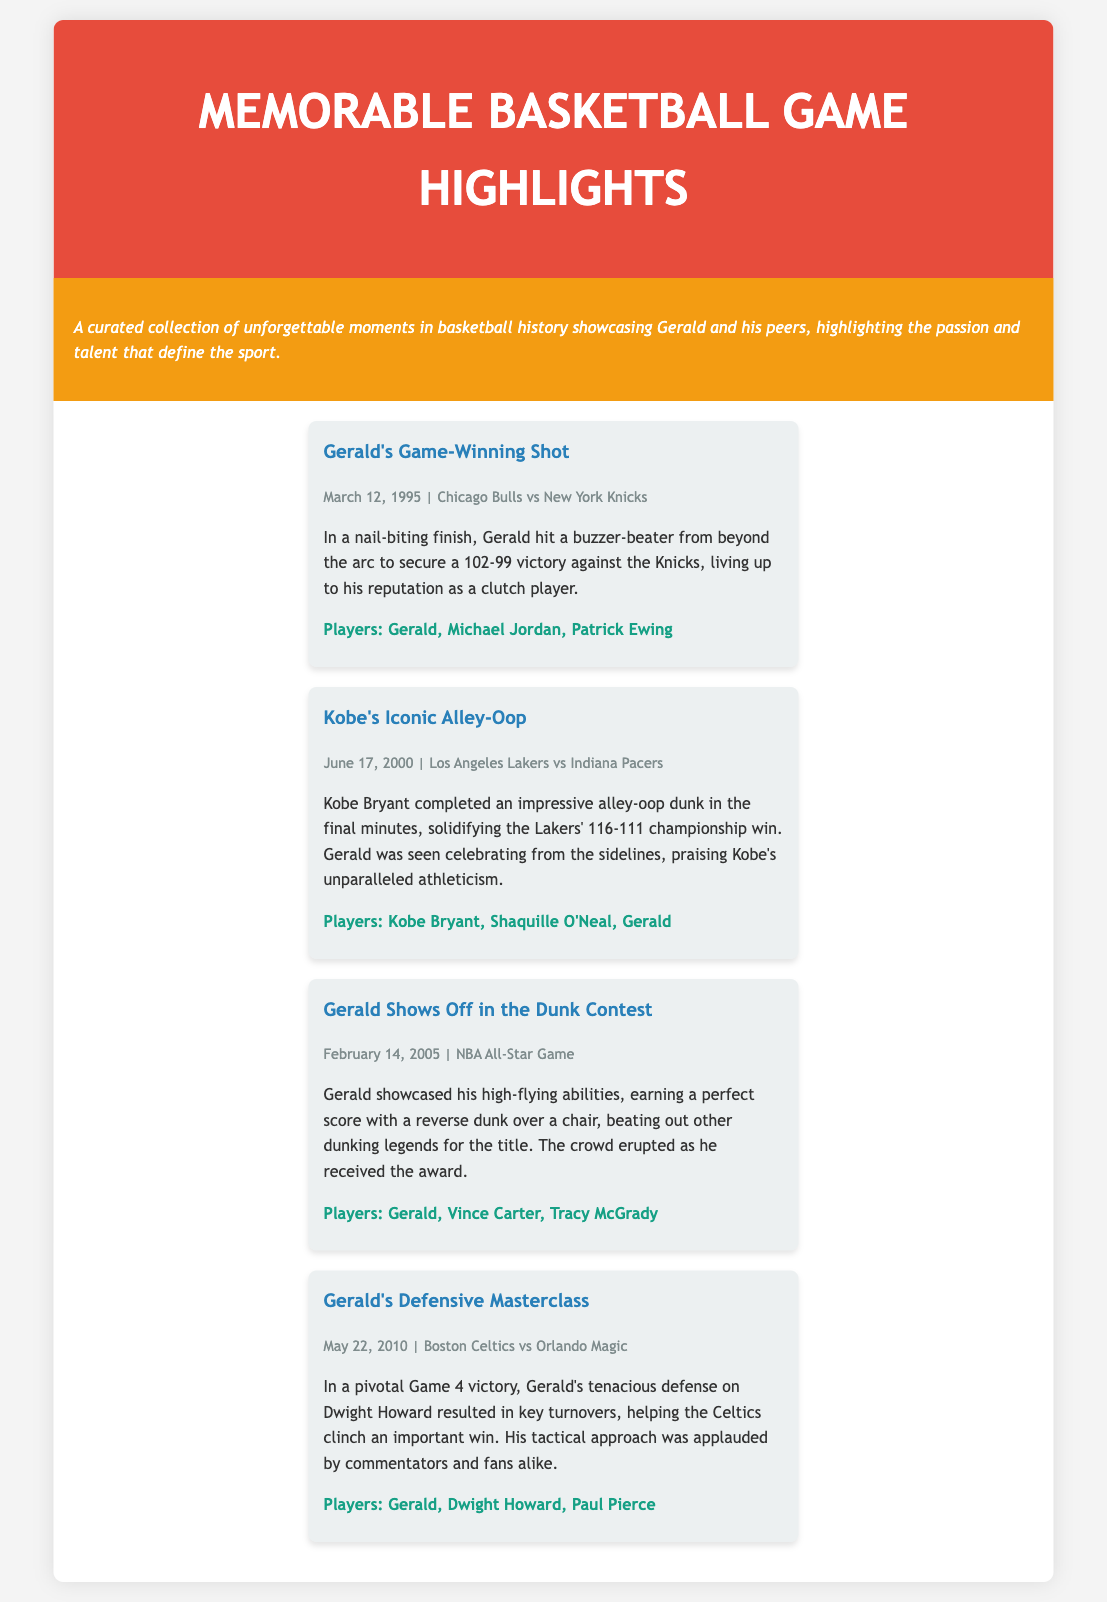What was Gerald's memorable game-winning moment? Gerald hit a buzzer-beater from beyond the arc against the Knicks on March 12, 1995.
Answer: buzzer-beater What teams played in Gerald's game-winning shot? The teams in the game were the Chicago Bulls and New York Knicks.
Answer: Chicago Bulls vs New York Knicks Who was involved in the highlight of Kobe's iconic alley-oop? The players involved in the highlight were Kobe Bryant, Shaquille O'Neal, and Gerald.
Answer: Kobe Bryant, Shaquille O'Neal, Gerald When did Gerald participate in the Dunk Contest? Gerald showcased his abilities in the Dunk Contest during the NBA All-Star Game on February 14, 2005.
Answer: February 14, 2005 What was the outcome of Gerald's defensive effort against Dwight Howard? Gerald's defense helped the Celtics clinch an important win in Game 4 against the Magic.
Answer: clinch an important win How many highlights feature Gerald in this collection? There are four highlights featuring Gerald in the collection.
Answer: four Which player did Gerald compete against in the Dunk Contest? Gerald competed against Vince Carter and Tracy McGrady in the Dunk Contest.
Answer: Vince Carter, Tracy McGrady What date did Kobe Bryant make his iconic alley-oop? Kobe made his iconic alley-oop on June 17, 2000.
Answer: June 17, 2000 What was the final score of the game where Gerald made his game-winning shot? The final score of the game was 102-99.
Answer: 102-99 